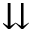<formula> <loc_0><loc_0><loc_500><loc_500>\downdownarrows</formula> 